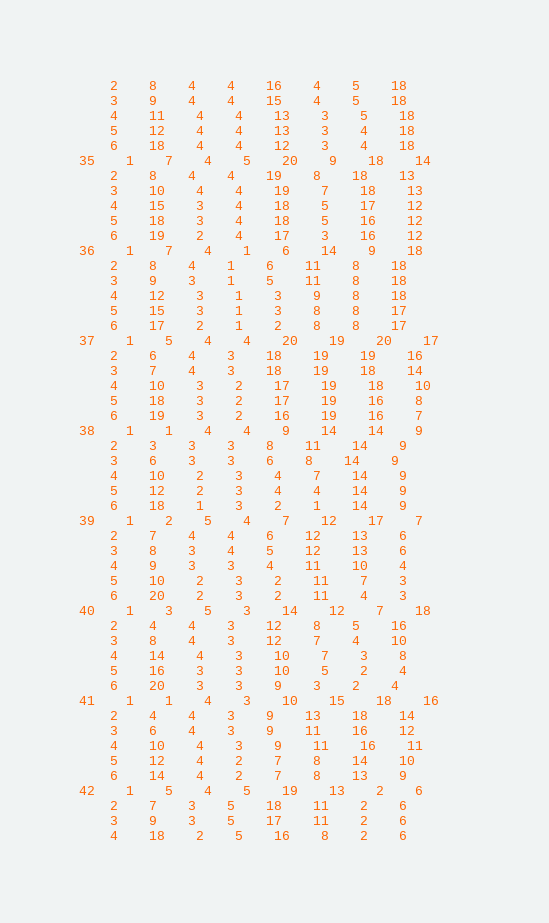Convert code to text. <code><loc_0><loc_0><loc_500><loc_500><_ObjectiveC_>	2	8	4	4	16	4	5	18	
	3	9	4	4	15	4	5	18	
	4	11	4	4	13	3	5	18	
	5	12	4	4	13	3	4	18	
	6	18	4	4	12	3	4	18	
35	1	7	4	5	20	9	18	14	
	2	8	4	4	19	8	18	13	
	3	10	4	4	19	7	18	13	
	4	15	3	4	18	5	17	12	
	5	18	3	4	18	5	16	12	
	6	19	2	4	17	3	16	12	
36	1	7	4	1	6	14	9	18	
	2	8	4	1	6	11	8	18	
	3	9	3	1	5	11	8	18	
	4	12	3	1	3	9	8	18	
	5	15	3	1	3	8	8	17	
	6	17	2	1	2	8	8	17	
37	1	5	4	4	20	19	20	17	
	2	6	4	3	18	19	19	16	
	3	7	4	3	18	19	18	14	
	4	10	3	2	17	19	18	10	
	5	18	3	2	17	19	16	8	
	6	19	3	2	16	19	16	7	
38	1	1	4	4	9	14	14	9	
	2	3	3	3	8	11	14	9	
	3	6	3	3	6	8	14	9	
	4	10	2	3	4	7	14	9	
	5	12	2	3	4	4	14	9	
	6	18	1	3	2	1	14	9	
39	1	2	5	4	7	12	17	7	
	2	7	4	4	6	12	13	6	
	3	8	3	4	5	12	13	6	
	4	9	3	3	4	11	10	4	
	5	10	2	3	2	11	7	3	
	6	20	2	3	2	11	4	3	
40	1	3	5	3	14	12	7	18	
	2	4	4	3	12	8	5	16	
	3	8	4	3	12	7	4	10	
	4	14	4	3	10	7	3	8	
	5	16	3	3	10	5	2	4	
	6	20	3	3	9	3	2	4	
41	1	1	4	3	10	15	18	16	
	2	4	4	3	9	13	18	14	
	3	6	4	3	9	11	16	12	
	4	10	4	3	9	11	16	11	
	5	12	4	2	7	8	14	10	
	6	14	4	2	7	8	13	9	
42	1	5	4	5	19	13	2	6	
	2	7	3	5	18	11	2	6	
	3	9	3	5	17	11	2	6	
	4	18	2	5	16	8	2	6	</code> 